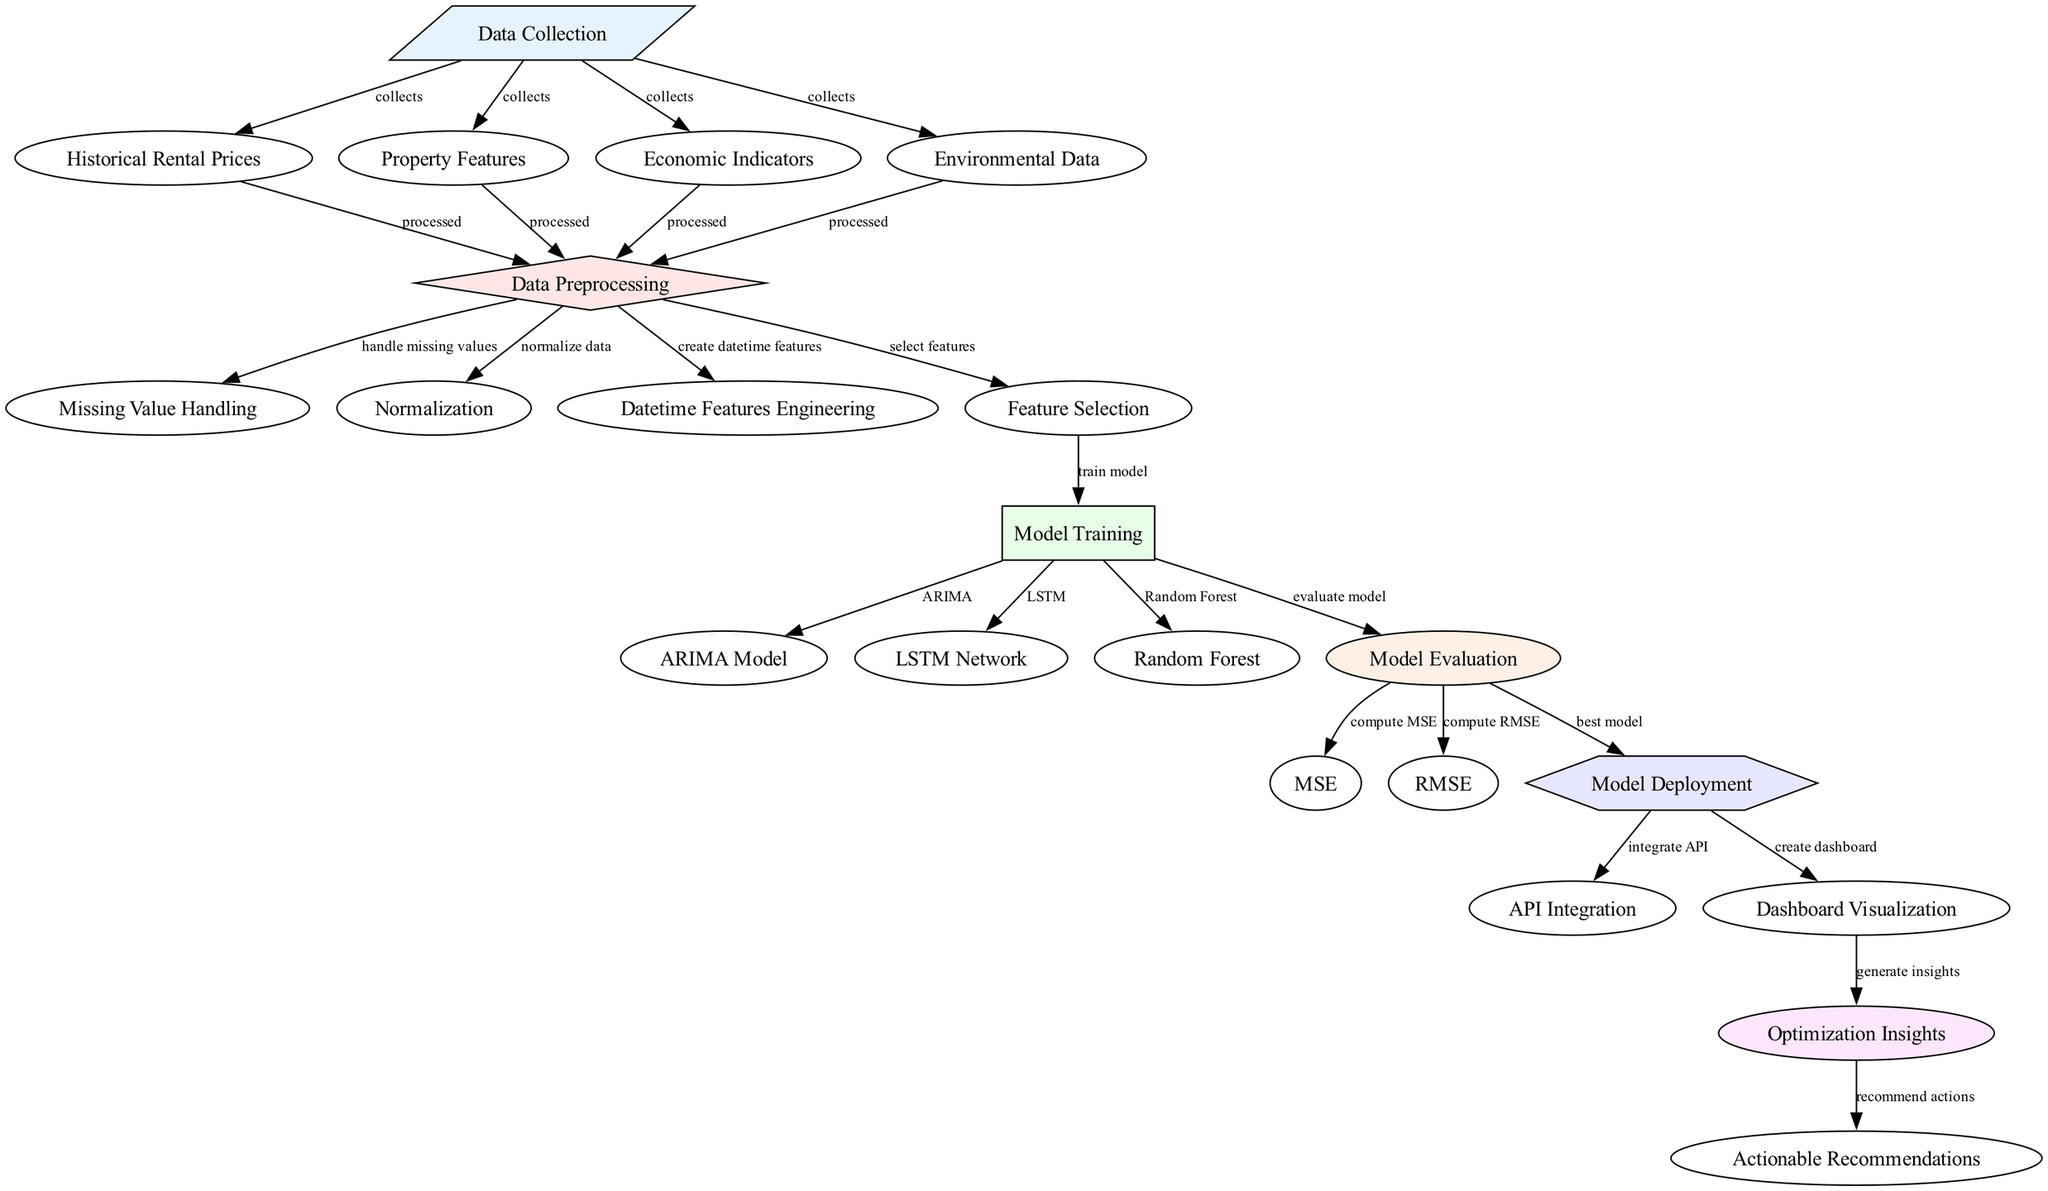What is the first step in the diagram? The diagram starts with "Data Collection," which is the first node listed. It indicates that the initial step involves gathering relevant data before any further processing or analysis can occur.
Answer: Data Collection How many nodes are present in the diagram? By counting all the individual components labeled in the diagram, we can see there are a total of twenty-two distinct nodes representing various steps and elements in the process.
Answer: Twenty-two Which model is evaluated after getting trained? The "Model Evaluation" node follows the "Model Training" node, where each of the trained models (ARIMA, LSTM, Random Forest) is assessed for performance.
Answer: All models What type of information is handled in the "Data Preprocessing" step? The "Data Preprocessing" node encompasses several tasks including handling missing values, normalizing data, creating datetime features, and selecting features, demonstrating the complexity of preparing the data for modeling.
Answer: Missing values, normalization, datetime features, feature selection How is the best model determined? After evaluating the models, indicated by the "Model Evaluation" node leading to "Model Deployment," the best performing model is selected based on evaluation metrics like MSE and RMSE, showing a logical flow of determining the most effective strategy for deployment.
Answer: Best model What insights are generated following the dashboard visualization? Post the creation of the dashboard visualization, the "Optimization Insights" node generates insights that are then translated into actionable recommendations, demonstrating the cyclical nature of data analysis in deriving practical outcomes.
Answer: Optimization Insights Which node directly follows "Model Training"? The "Model Evaluation" node directly follows the "Model Training" node, indicating a sequential process where performance metrics are computed after the models have been trained against the dataset.
Answer: Model Evaluation What are the evaluation metrics computed in the diagram? The diagram specifies two evaluation metrics, MSE (Mean Squared Error) and RMSE (Root Mean Squared Error), which are computed to assess the models' performance, highlighting the importance of quantifying model accuracy.
Answer: Mean Squared Error and Root Mean Squared Error Which step utilizes "API Integration"? The "API Integration" step follows the "Model Deployment," indicating that after deploying the model, it is essential to integrate it with other applications or services for accessibility and functionality.
Answer: API Integration 